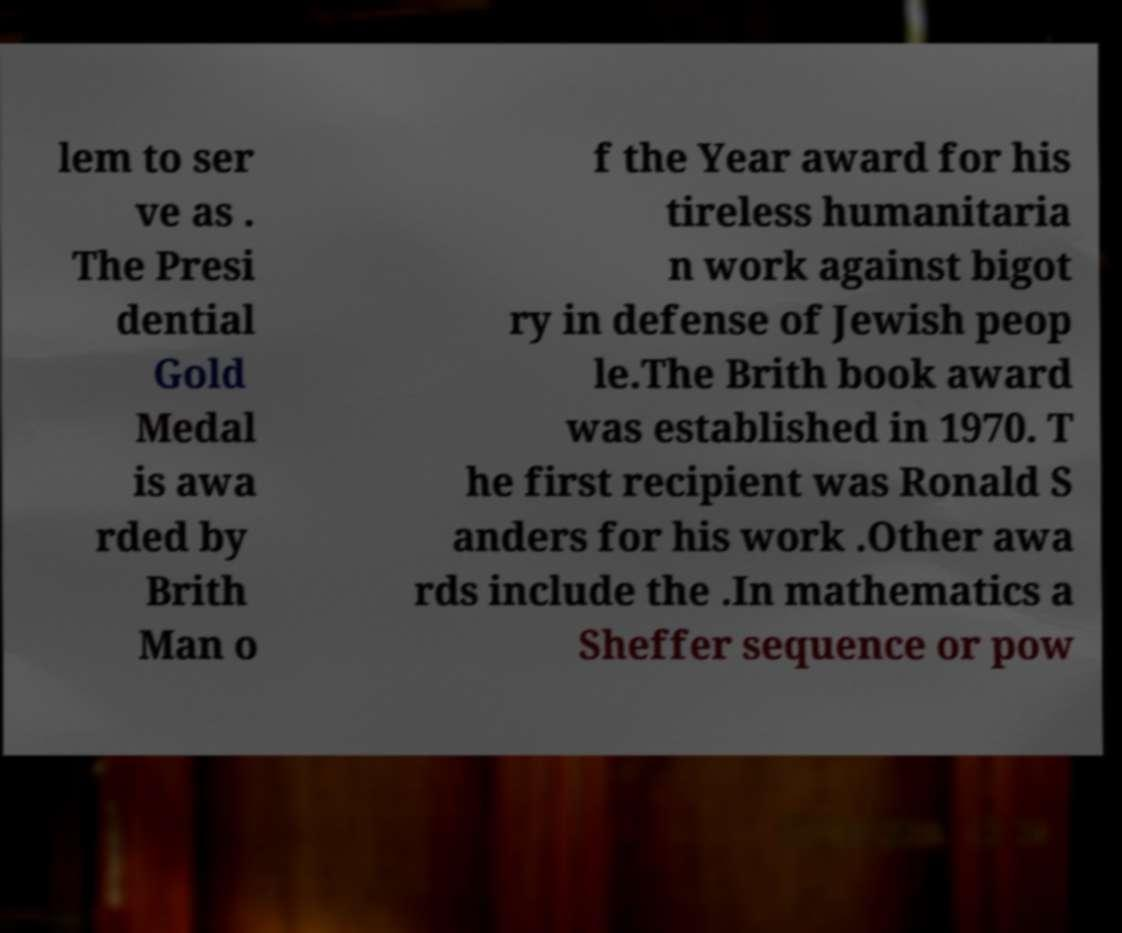Could you extract and type out the text from this image? lem to ser ve as . The Presi dential Gold Medal is awa rded by Brith Man o f the Year award for his tireless humanitaria n work against bigot ry in defense of Jewish peop le.The Brith book award was established in 1970. T he first recipient was Ronald S anders for his work .Other awa rds include the .In mathematics a Sheffer sequence or pow 